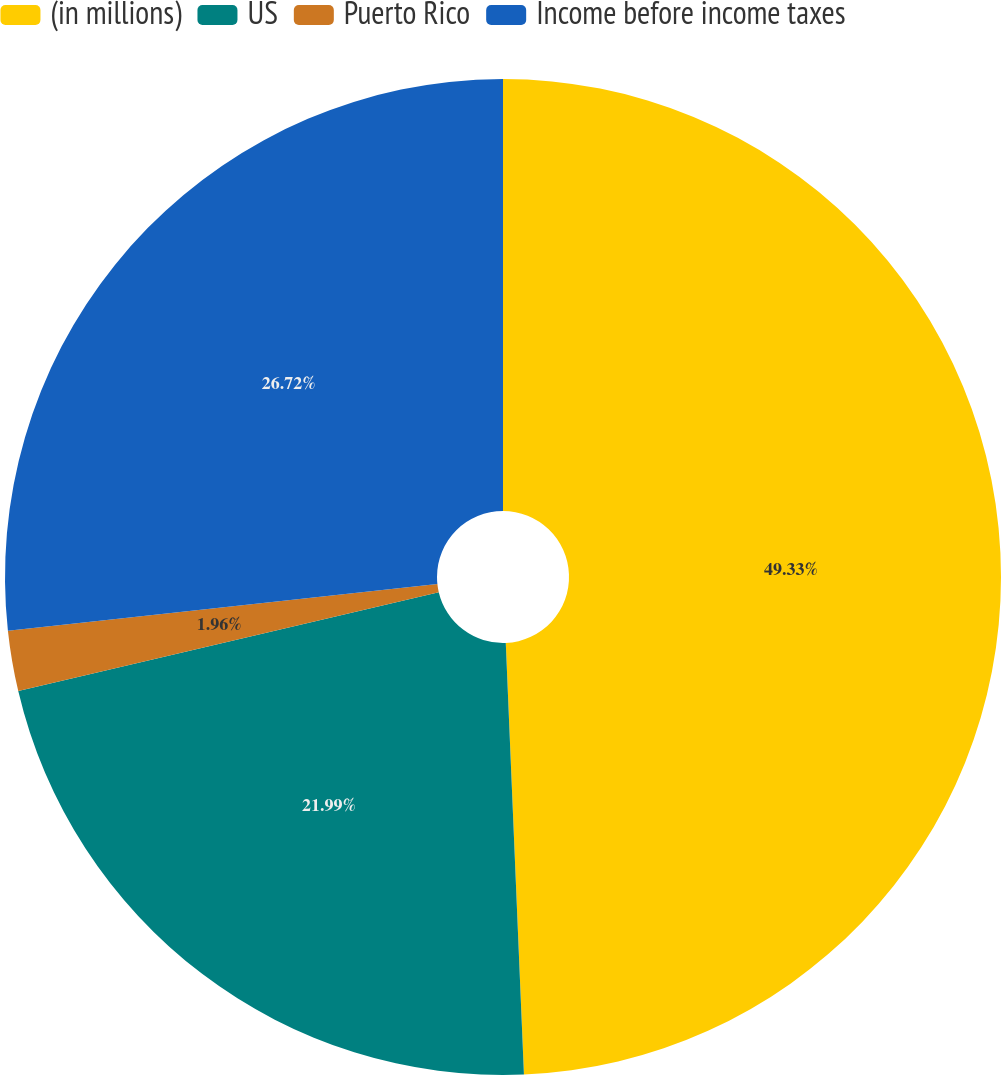Convert chart to OTSL. <chart><loc_0><loc_0><loc_500><loc_500><pie_chart><fcel>(in millions)<fcel>US<fcel>Puerto Rico<fcel>Income before income taxes<nl><fcel>49.33%<fcel>21.99%<fcel>1.96%<fcel>26.72%<nl></chart> 